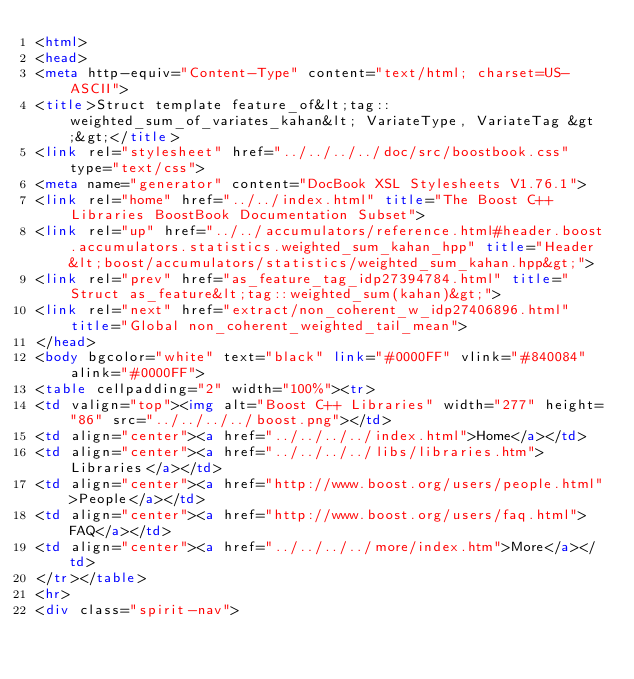<code> <loc_0><loc_0><loc_500><loc_500><_HTML_><html>
<head>
<meta http-equiv="Content-Type" content="text/html; charset=US-ASCII">
<title>Struct template feature_of&lt;tag::weighted_sum_of_variates_kahan&lt; VariateType, VariateTag &gt;&gt;</title>
<link rel="stylesheet" href="../../../../doc/src/boostbook.css" type="text/css">
<meta name="generator" content="DocBook XSL Stylesheets V1.76.1">
<link rel="home" href="../../index.html" title="The Boost C++ Libraries BoostBook Documentation Subset">
<link rel="up" href="../../accumulators/reference.html#header.boost.accumulators.statistics.weighted_sum_kahan_hpp" title="Header &lt;boost/accumulators/statistics/weighted_sum_kahan.hpp&gt;">
<link rel="prev" href="as_feature_tag_idp27394784.html" title="Struct as_feature&lt;tag::weighted_sum(kahan)&gt;">
<link rel="next" href="extract/non_coherent_w_idp27406896.html" title="Global non_coherent_weighted_tail_mean">
</head>
<body bgcolor="white" text="black" link="#0000FF" vlink="#840084" alink="#0000FF">
<table cellpadding="2" width="100%"><tr>
<td valign="top"><img alt="Boost C++ Libraries" width="277" height="86" src="../../../../boost.png"></td>
<td align="center"><a href="../../../../index.html">Home</a></td>
<td align="center"><a href="../../../../libs/libraries.htm">Libraries</a></td>
<td align="center"><a href="http://www.boost.org/users/people.html">People</a></td>
<td align="center"><a href="http://www.boost.org/users/faq.html">FAQ</a></td>
<td align="center"><a href="../../../../more/index.htm">More</a></td>
</tr></table>
<hr>
<div class="spirit-nav"></code> 